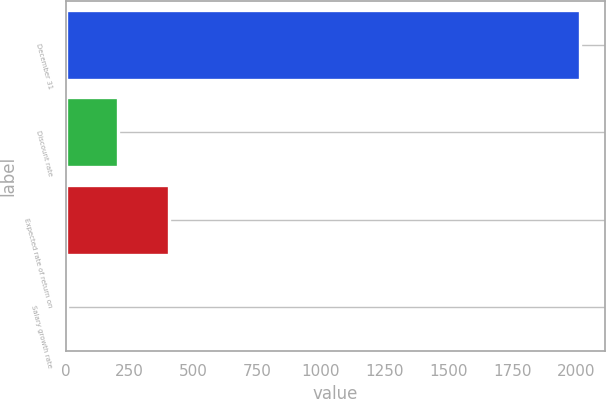Convert chart to OTSL. <chart><loc_0><loc_0><loc_500><loc_500><bar_chart><fcel>December 31<fcel>Discount rate<fcel>Expected rate of return on<fcel>Salary growth rate<nl><fcel>2013<fcel>204.27<fcel>405.24<fcel>3.3<nl></chart> 